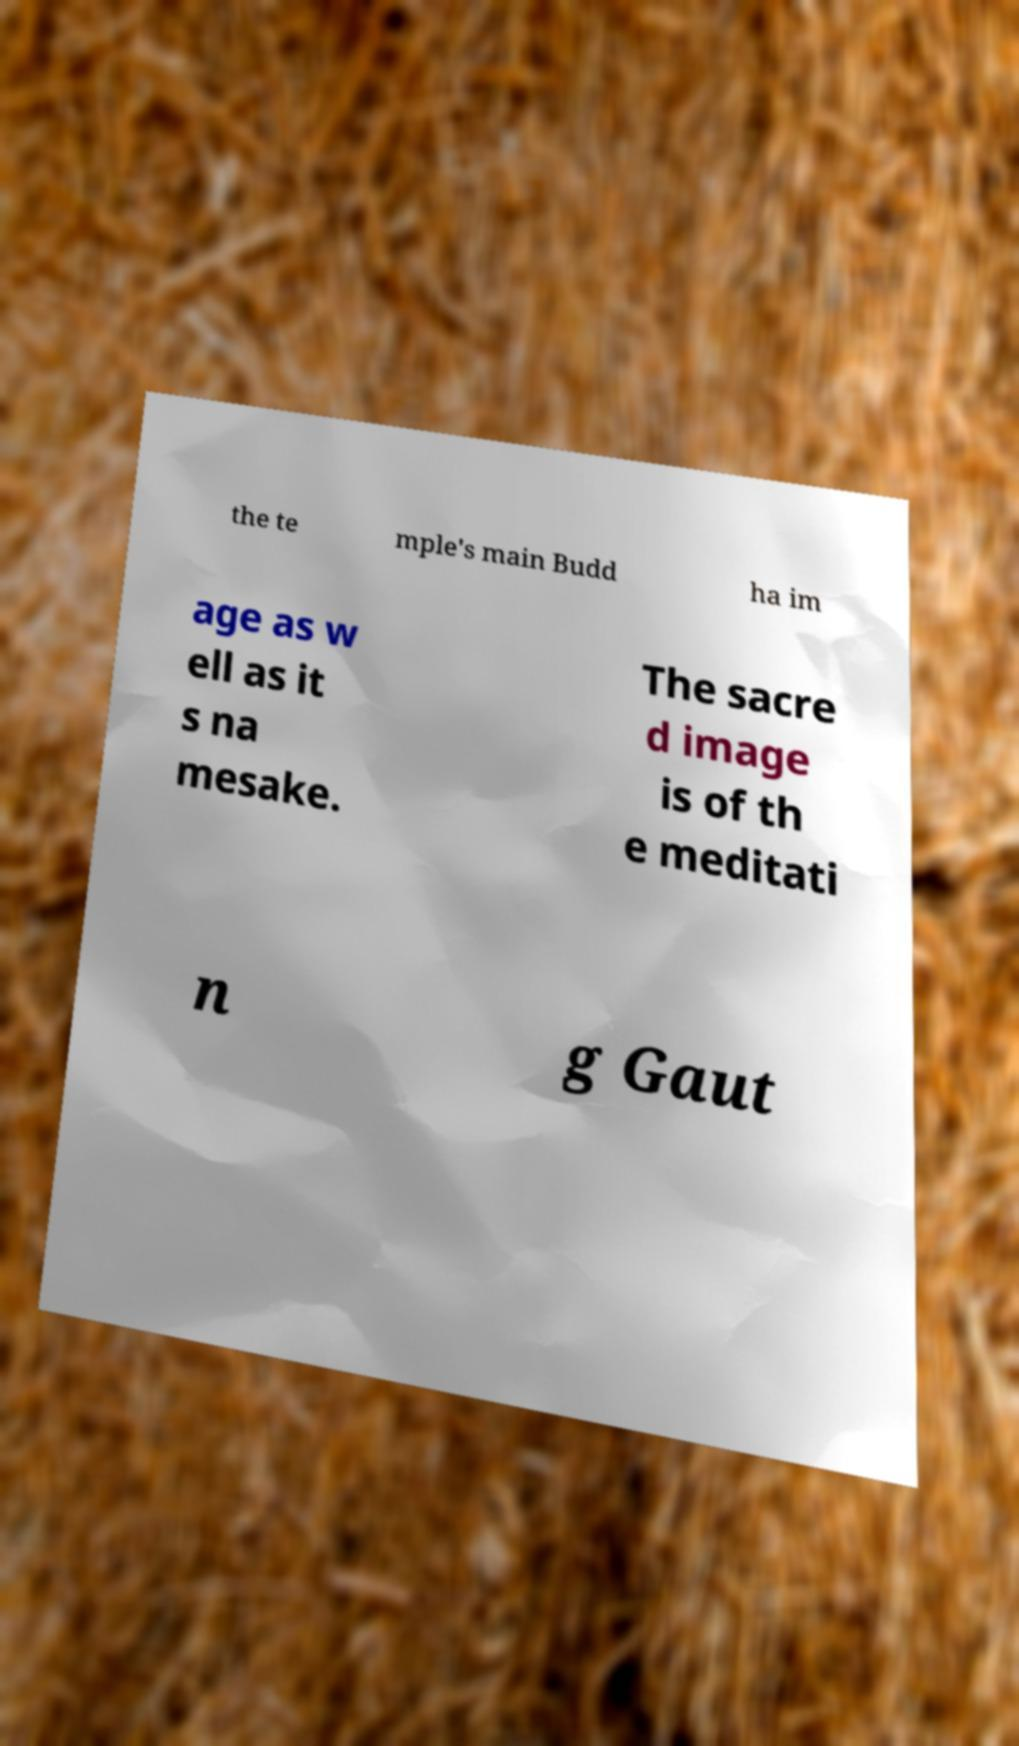I need the written content from this picture converted into text. Can you do that? the te mple's main Budd ha im age as w ell as it s na mesake. The sacre d image is of th e meditati n g Gaut 